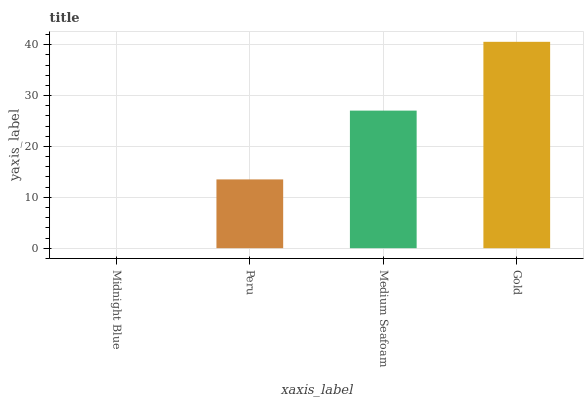Is Midnight Blue the minimum?
Answer yes or no. Yes. Is Gold the maximum?
Answer yes or no. Yes. Is Peru the minimum?
Answer yes or no. No. Is Peru the maximum?
Answer yes or no. No. Is Peru greater than Midnight Blue?
Answer yes or no. Yes. Is Midnight Blue less than Peru?
Answer yes or no. Yes. Is Midnight Blue greater than Peru?
Answer yes or no. No. Is Peru less than Midnight Blue?
Answer yes or no. No. Is Medium Seafoam the high median?
Answer yes or no. Yes. Is Peru the low median?
Answer yes or no. Yes. Is Gold the high median?
Answer yes or no. No. Is Midnight Blue the low median?
Answer yes or no. No. 